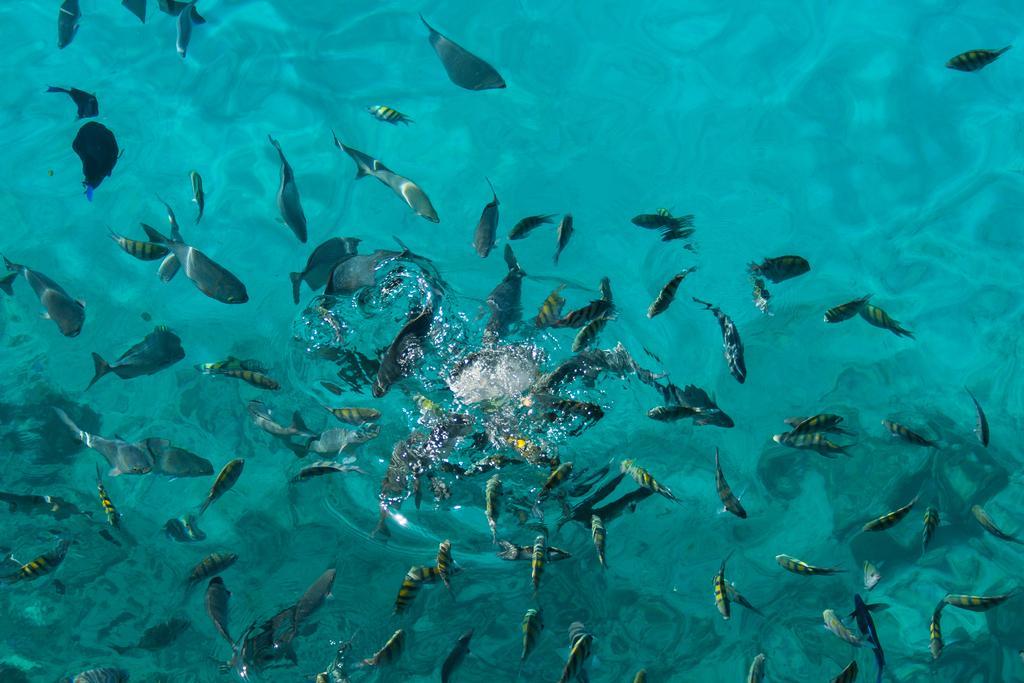How would you summarize this image in a sentence or two? In this image we can see so many fish in the water. 